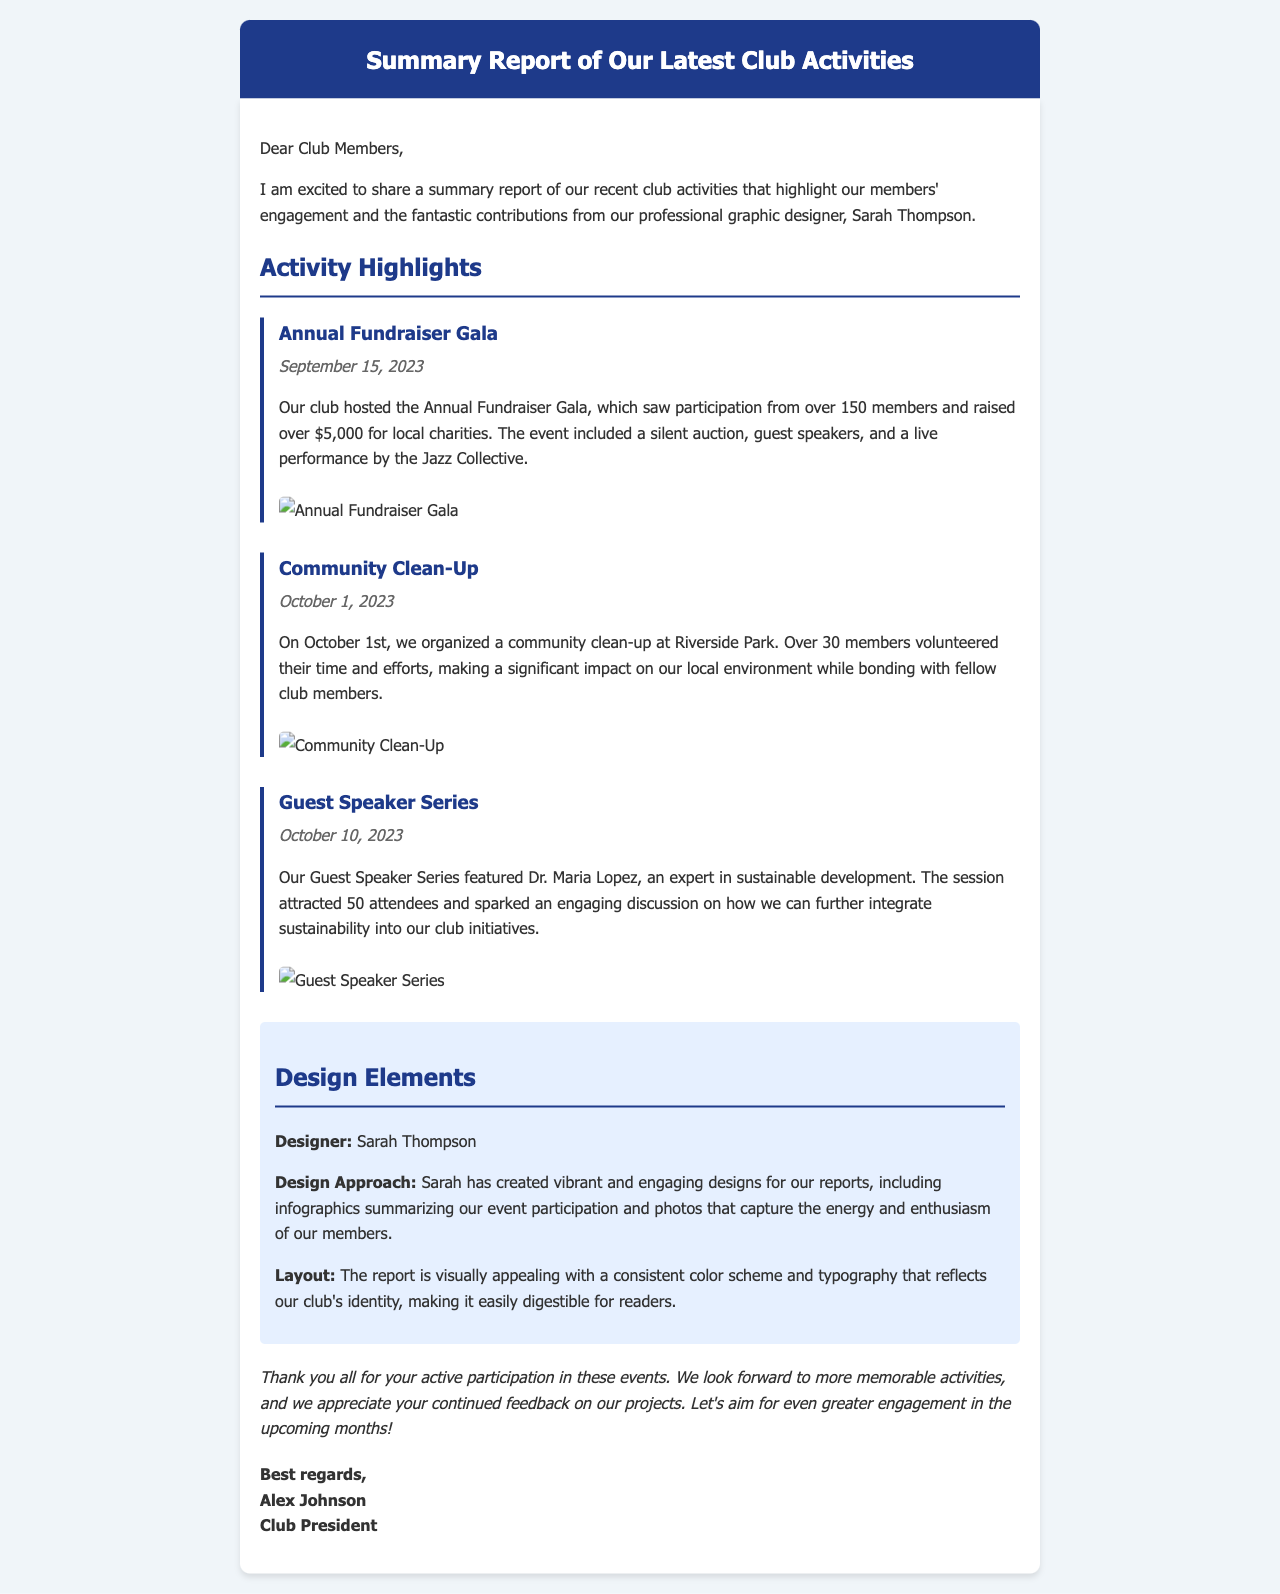What is the title of the report? The title of the report is presented in the header of the document.
Answer: Summary Report of Our Latest Club Activities Who is the designer mentioned in the document? The designer's name is highlighted in the designer section of the report.
Answer: Sarah Thompson How many members participated in the Annual Fundraiser Gala? The number of participants at the gala is mentioned in the activity highlight section.
Answer: over 150 members What was the date of the Community Clean-Up event? The date of the event is specified under the Community Clean-Up activity.
Answer: October 1, 2023 What amount was raised during the Annual Fundraiser Gala? The fundraising amount is stated within the description of the gala event.
Answer: over $5,000 How many attendees were at the Guest Speaker Series? The document states the number of attendees in the Guest Speaker Series section.
Answer: 50 attendees What is the design approach used by Sarah? The design approach is described in the designer section of the report.
Answer: vibrant and engaging designs Which event featured Dr. Maria Lopez? The document specifies which event Dr. Maria Lopez participated in.
Answer: Guest Speaker Series What is the purpose of the summary report? The purpose can be inferred from the introduction paragraph of the report.
Answer: highlight our members' engagement 